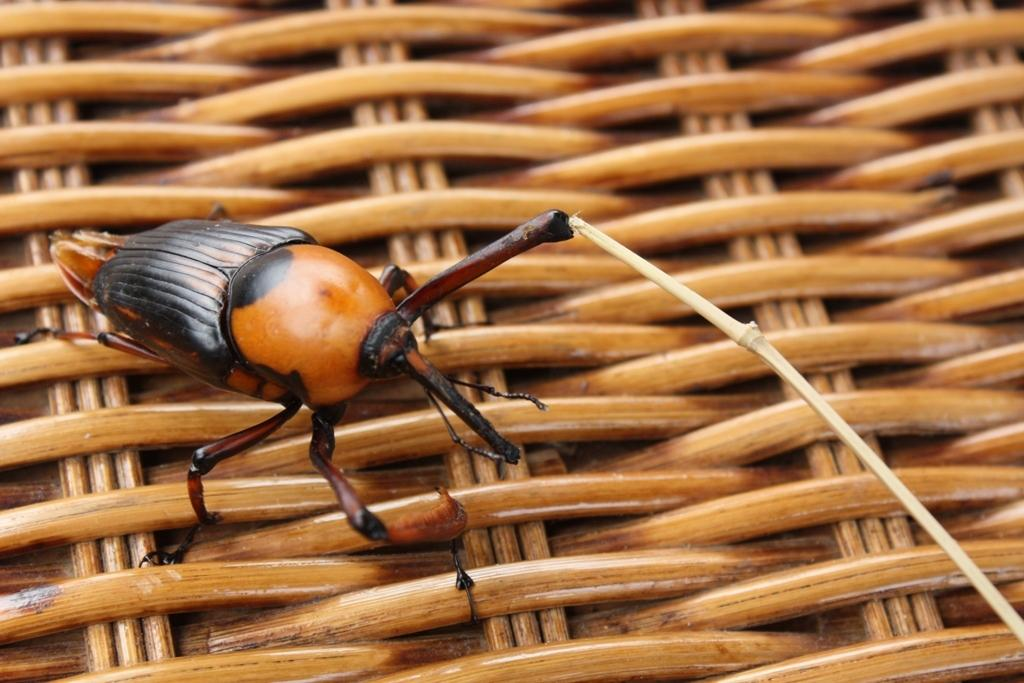What type of creature can be seen in the image? There is an insect in the image. What is the insect located on? The insect is on a wooden object. How many geese are flying in the image? There are no geese present in the image; it features an insect on a wooden object. What form does the ghost take in the image? There is no ghost present in the image. 